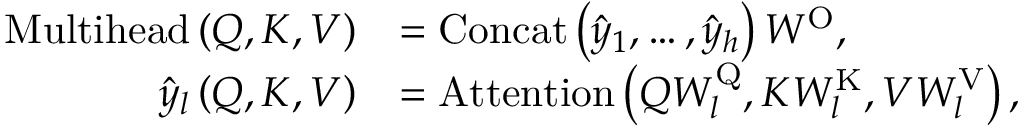Convert formula to latex. <formula><loc_0><loc_0><loc_500><loc_500>\begin{array} { r l } { M u l t i h e a d \left ( Q , K , V \right ) } & { = C o n c a t \left ( \hat { y } _ { 1 } , \dots , \hat { y } _ { h } \right ) W ^ { O } , } \\ { \hat { y } _ { l } \left ( Q , K , V \right ) } & { = A t t e n t i o n \left ( Q W _ { l } ^ { Q } , K W _ { l } ^ { K } , V W _ { l } ^ { V } \right ) , } \end{array}</formula> 